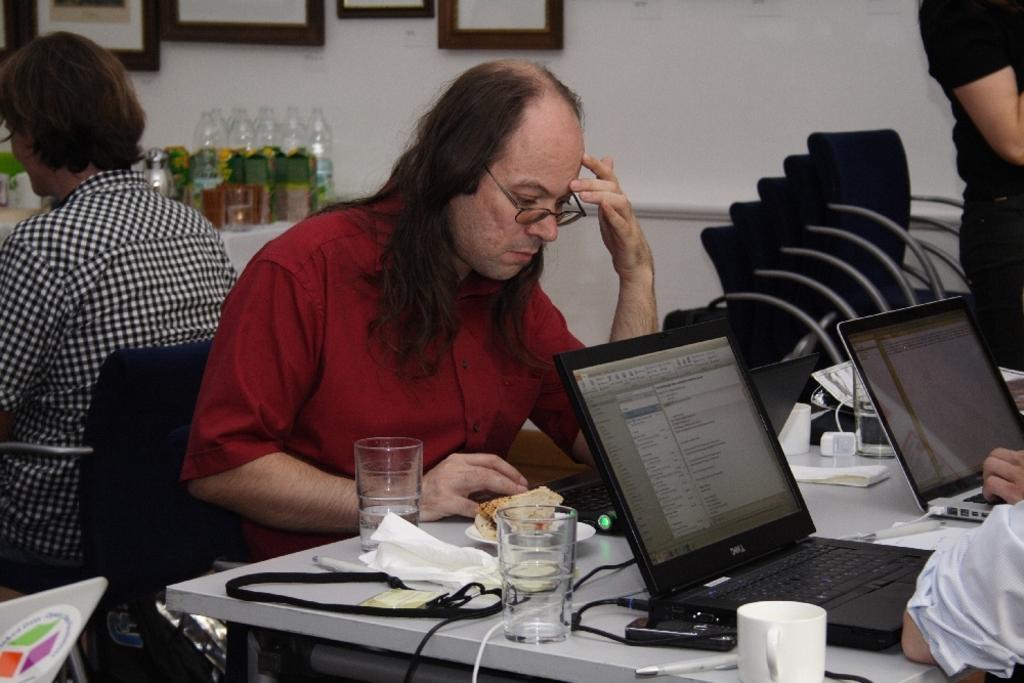Can you describe this image briefly? In this picture a guy is sitting on a table with food eatables on top of it. We also observe few laptops , in the background there are photo frames,glass bottles, empty chairs. 